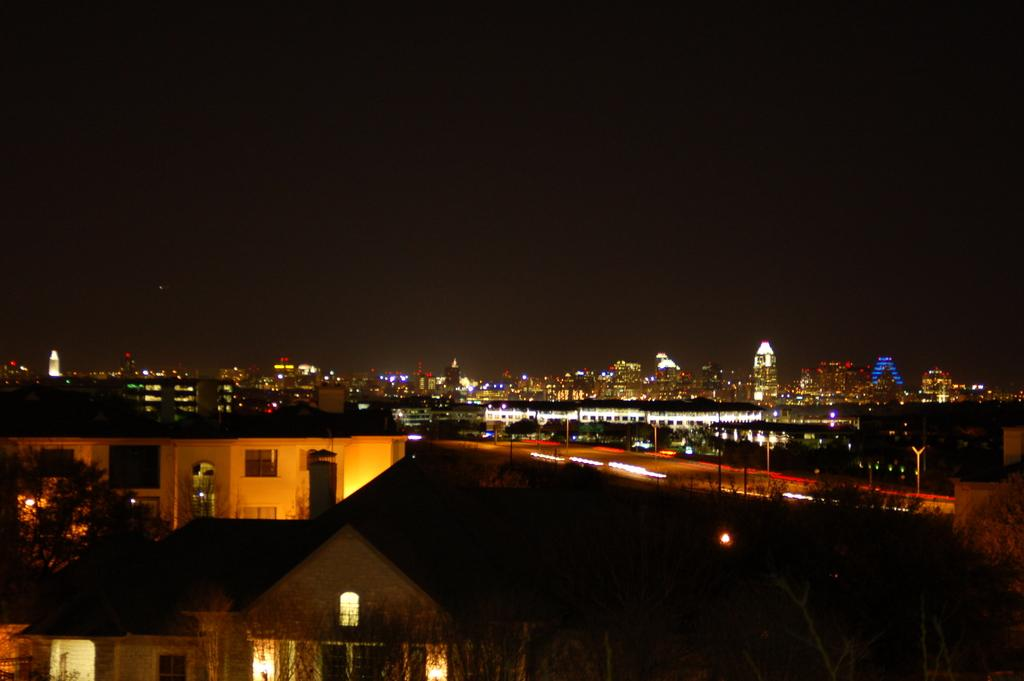What type of structures can be seen in the image? There are buildings in the image. What is located in the front of the image? There are trees in the front of the image. What can be seen in the background of the image? There are buildings, lights, poles, and trees in the background of the image. What type of bed can be seen in the image? There is no bed present in the image. What is the chin of the duck doing in the image? There is no duck or chin present in the image. 